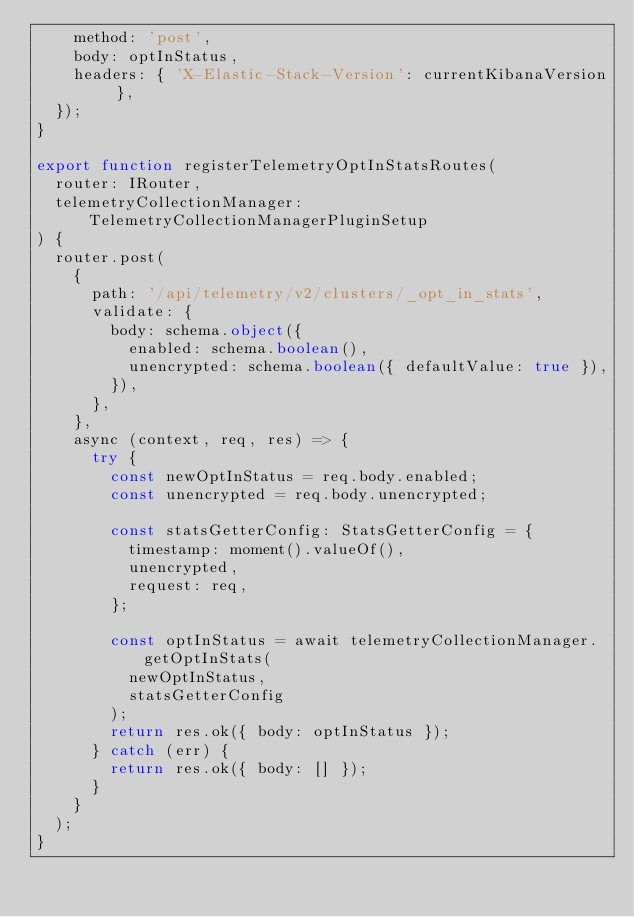Convert code to text. <code><loc_0><loc_0><loc_500><loc_500><_TypeScript_>    method: 'post',
    body: optInStatus,
    headers: { 'X-Elastic-Stack-Version': currentKibanaVersion },
  });
}

export function registerTelemetryOptInStatsRoutes(
  router: IRouter,
  telemetryCollectionManager: TelemetryCollectionManagerPluginSetup
) {
  router.post(
    {
      path: '/api/telemetry/v2/clusters/_opt_in_stats',
      validate: {
        body: schema.object({
          enabled: schema.boolean(),
          unencrypted: schema.boolean({ defaultValue: true }),
        }),
      },
    },
    async (context, req, res) => {
      try {
        const newOptInStatus = req.body.enabled;
        const unencrypted = req.body.unencrypted;

        const statsGetterConfig: StatsGetterConfig = {
          timestamp: moment().valueOf(),
          unencrypted,
          request: req,
        };

        const optInStatus = await telemetryCollectionManager.getOptInStats(
          newOptInStatus,
          statsGetterConfig
        );
        return res.ok({ body: optInStatus });
      } catch (err) {
        return res.ok({ body: [] });
      }
    }
  );
}
</code> 